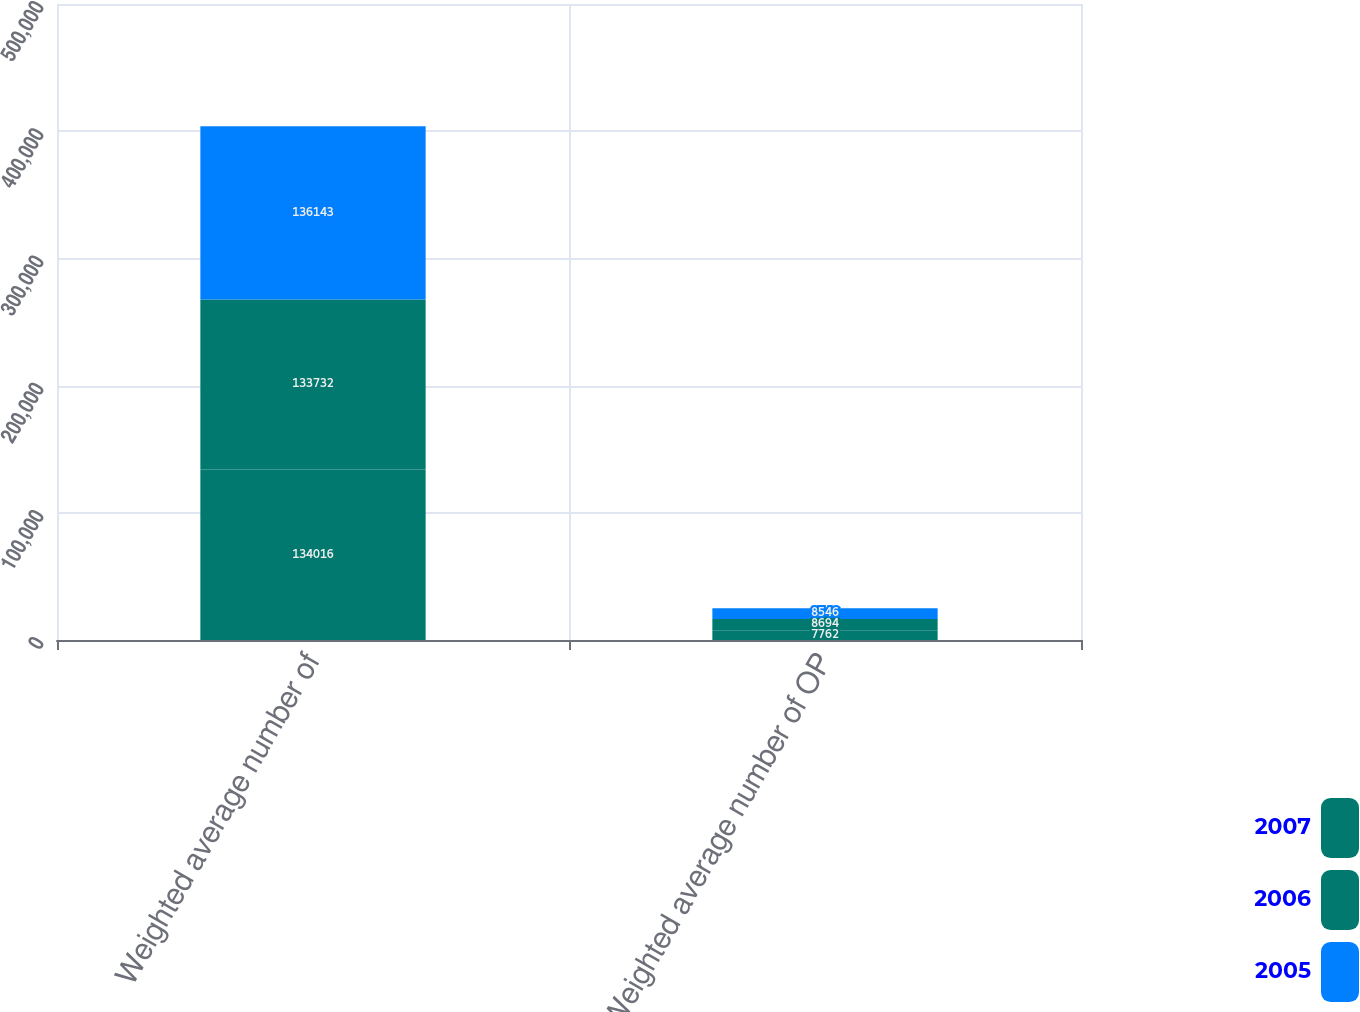<chart> <loc_0><loc_0><loc_500><loc_500><stacked_bar_chart><ecel><fcel>Weighted average number of<fcel>Weighted average number of OP<nl><fcel>2007<fcel>134016<fcel>7762<nl><fcel>2006<fcel>133732<fcel>8694<nl><fcel>2005<fcel>136143<fcel>8546<nl></chart> 